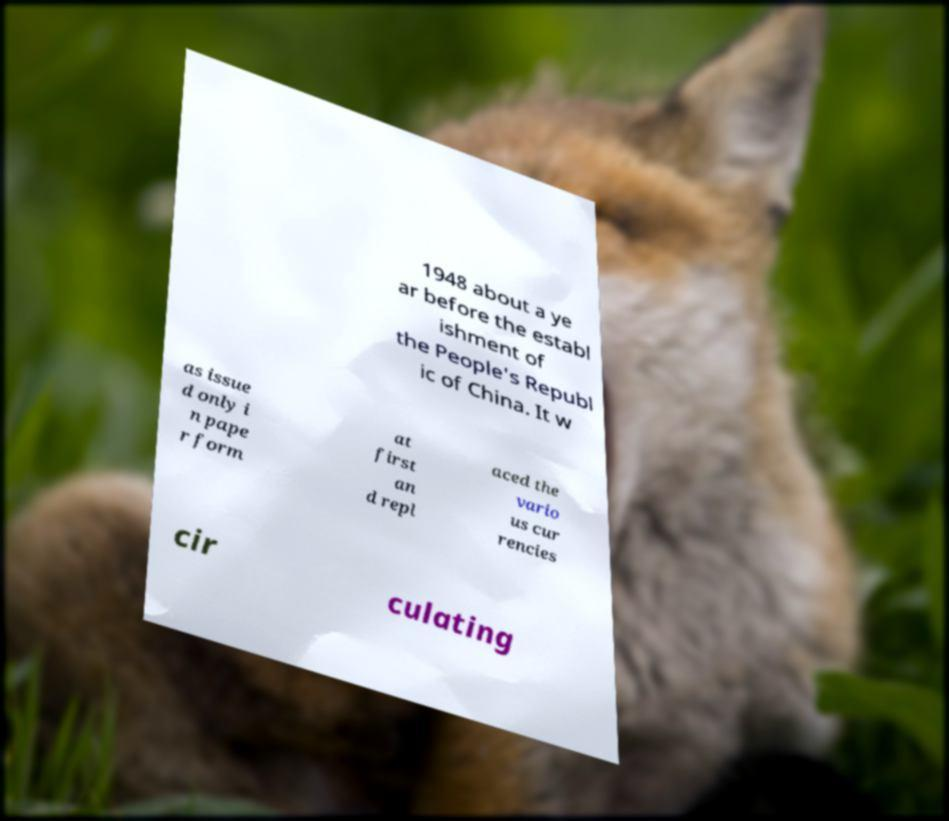For documentation purposes, I need the text within this image transcribed. Could you provide that? 1948 about a ye ar before the establ ishment of the People's Republ ic of China. It w as issue d only i n pape r form at first an d repl aced the vario us cur rencies cir culating 